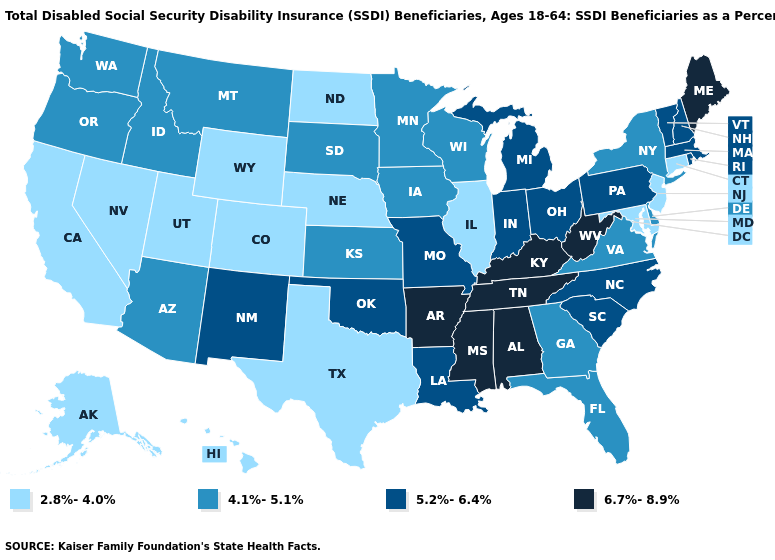Name the states that have a value in the range 4.1%-5.1%?
Give a very brief answer. Arizona, Delaware, Florida, Georgia, Idaho, Iowa, Kansas, Minnesota, Montana, New York, Oregon, South Dakota, Virginia, Washington, Wisconsin. Name the states that have a value in the range 6.7%-8.9%?
Keep it brief. Alabama, Arkansas, Kentucky, Maine, Mississippi, Tennessee, West Virginia. Name the states that have a value in the range 6.7%-8.9%?
Quick response, please. Alabama, Arkansas, Kentucky, Maine, Mississippi, Tennessee, West Virginia. Does Connecticut have the lowest value in the Northeast?
Quick response, please. Yes. Which states have the lowest value in the MidWest?
Answer briefly. Illinois, Nebraska, North Dakota. Name the states that have a value in the range 6.7%-8.9%?
Concise answer only. Alabama, Arkansas, Kentucky, Maine, Mississippi, Tennessee, West Virginia. What is the value of Pennsylvania?
Quick response, please. 5.2%-6.4%. Among the states that border California , does Arizona have the highest value?
Write a very short answer. Yes. Does Georgia have the lowest value in the USA?
Answer briefly. No. Which states have the lowest value in the MidWest?
Be succinct. Illinois, Nebraska, North Dakota. What is the lowest value in the USA?
Short answer required. 2.8%-4.0%. What is the value of Arizona?
Short answer required. 4.1%-5.1%. Does North Dakota have a lower value than California?
Give a very brief answer. No. Does the map have missing data?
Concise answer only. No. What is the value of Wisconsin?
Keep it brief. 4.1%-5.1%. 